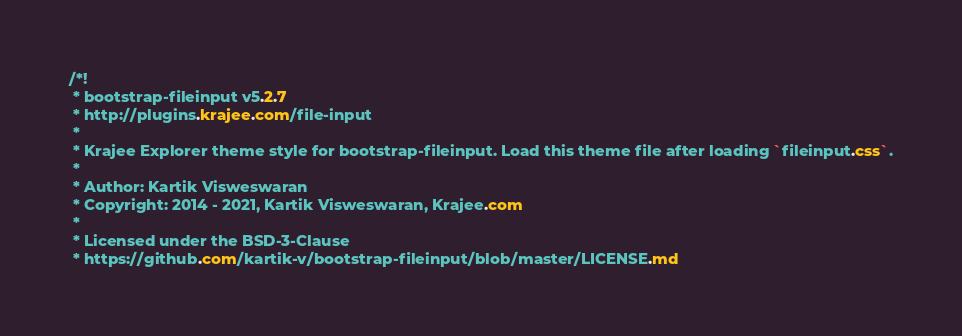<code> <loc_0><loc_0><loc_500><loc_500><_CSS_>/*!
 * bootstrap-fileinput v5.2.7
 * http://plugins.krajee.com/file-input
 *
 * Krajee Explorer theme style for bootstrap-fileinput. Load this theme file after loading `fileinput.css`.
 *
 * Author: Kartik Visweswaran
 * Copyright: 2014 - 2021, Kartik Visweswaran, Krajee.com
 *
 * Licensed under the BSD-3-Clause
 * https://github.com/kartik-v/bootstrap-fileinput/blob/master/LICENSE.md</code> 